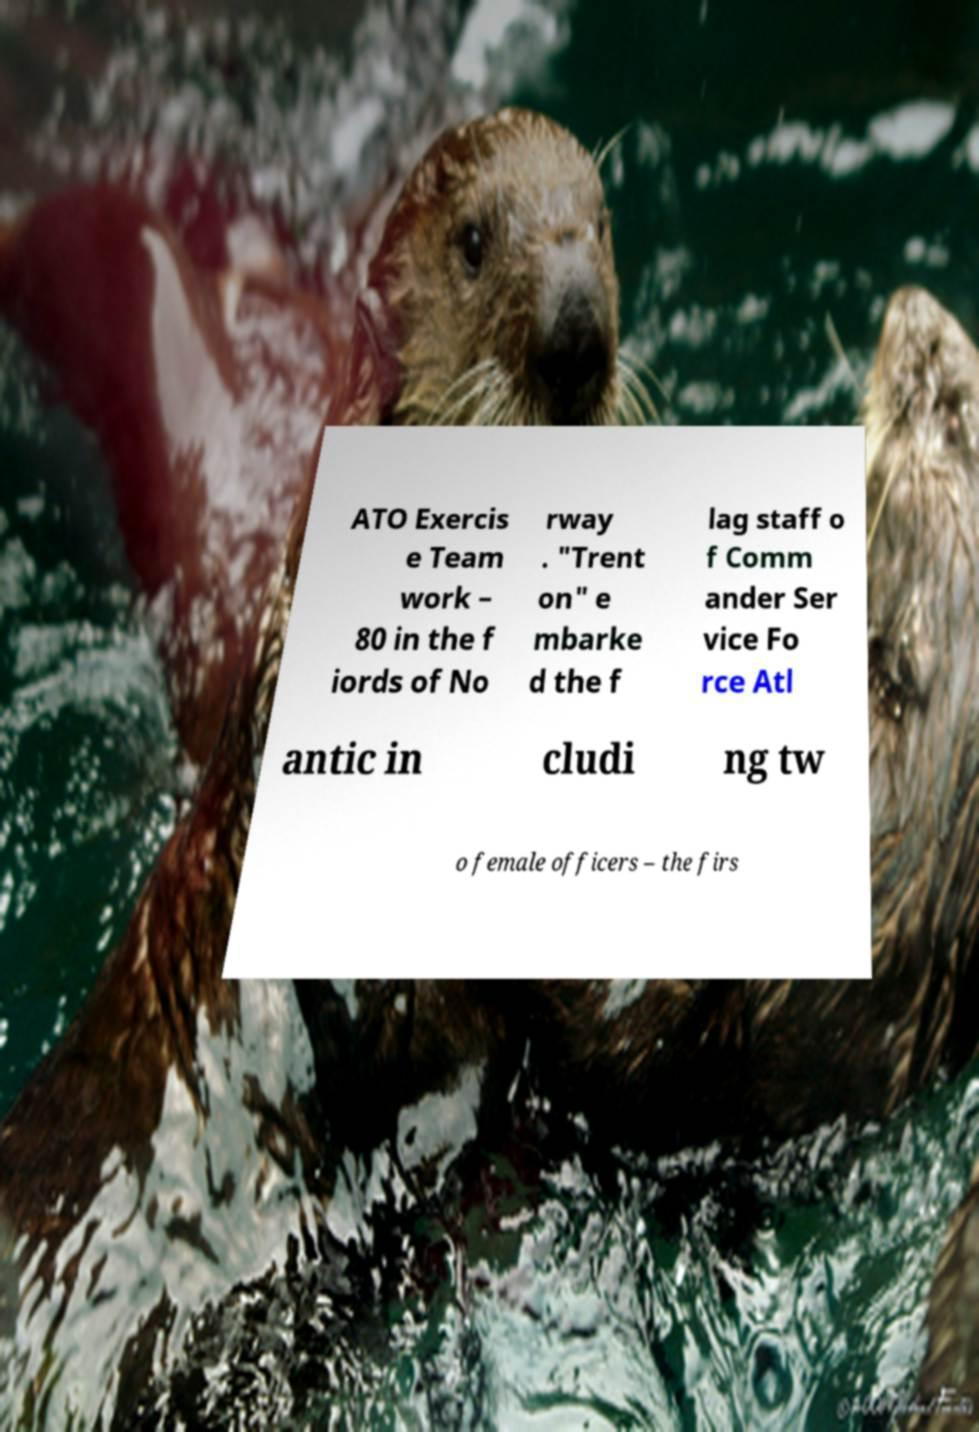Can you accurately transcribe the text from the provided image for me? ATO Exercis e Team work – 80 in the f iords of No rway . "Trent on" e mbarke d the f lag staff o f Comm ander Ser vice Fo rce Atl antic in cludi ng tw o female officers – the firs 